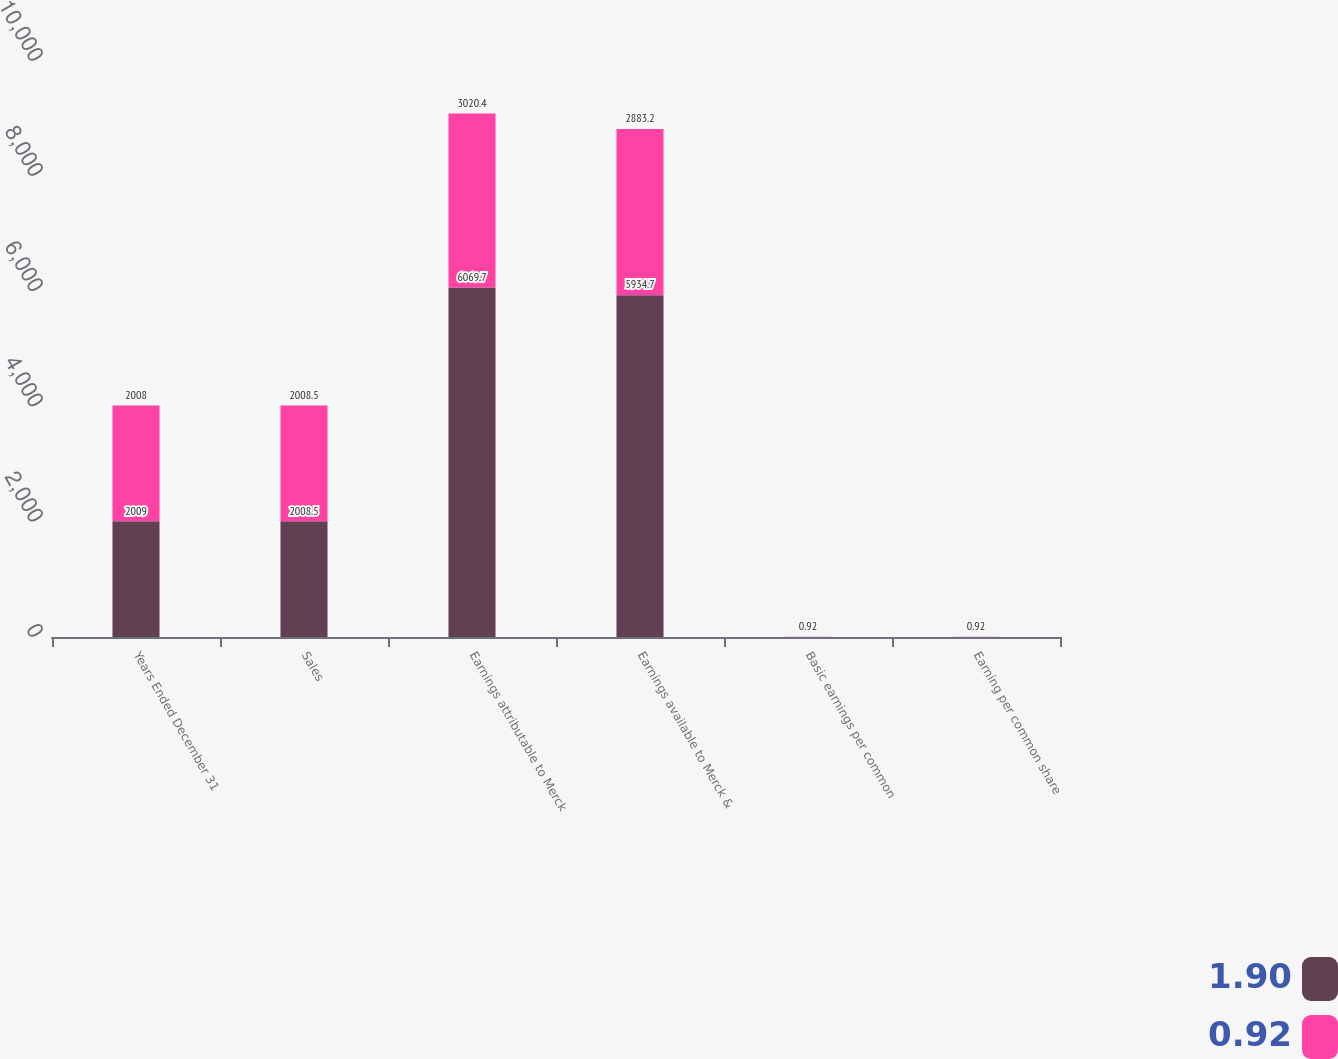Convert chart to OTSL. <chart><loc_0><loc_0><loc_500><loc_500><stacked_bar_chart><ecel><fcel>Years Ended December 31<fcel>Sales<fcel>Earnings attributable to Merck<fcel>Earnings available to Merck &<fcel>Basic earnings per common<fcel>Earning per common share<nl><fcel>1.9<fcel>2009<fcel>2008.5<fcel>6069.7<fcel>5934.7<fcel>1.91<fcel>1.9<nl><fcel>0.92<fcel>2008<fcel>2008.5<fcel>3020.4<fcel>2883.2<fcel>0.92<fcel>0.92<nl></chart> 